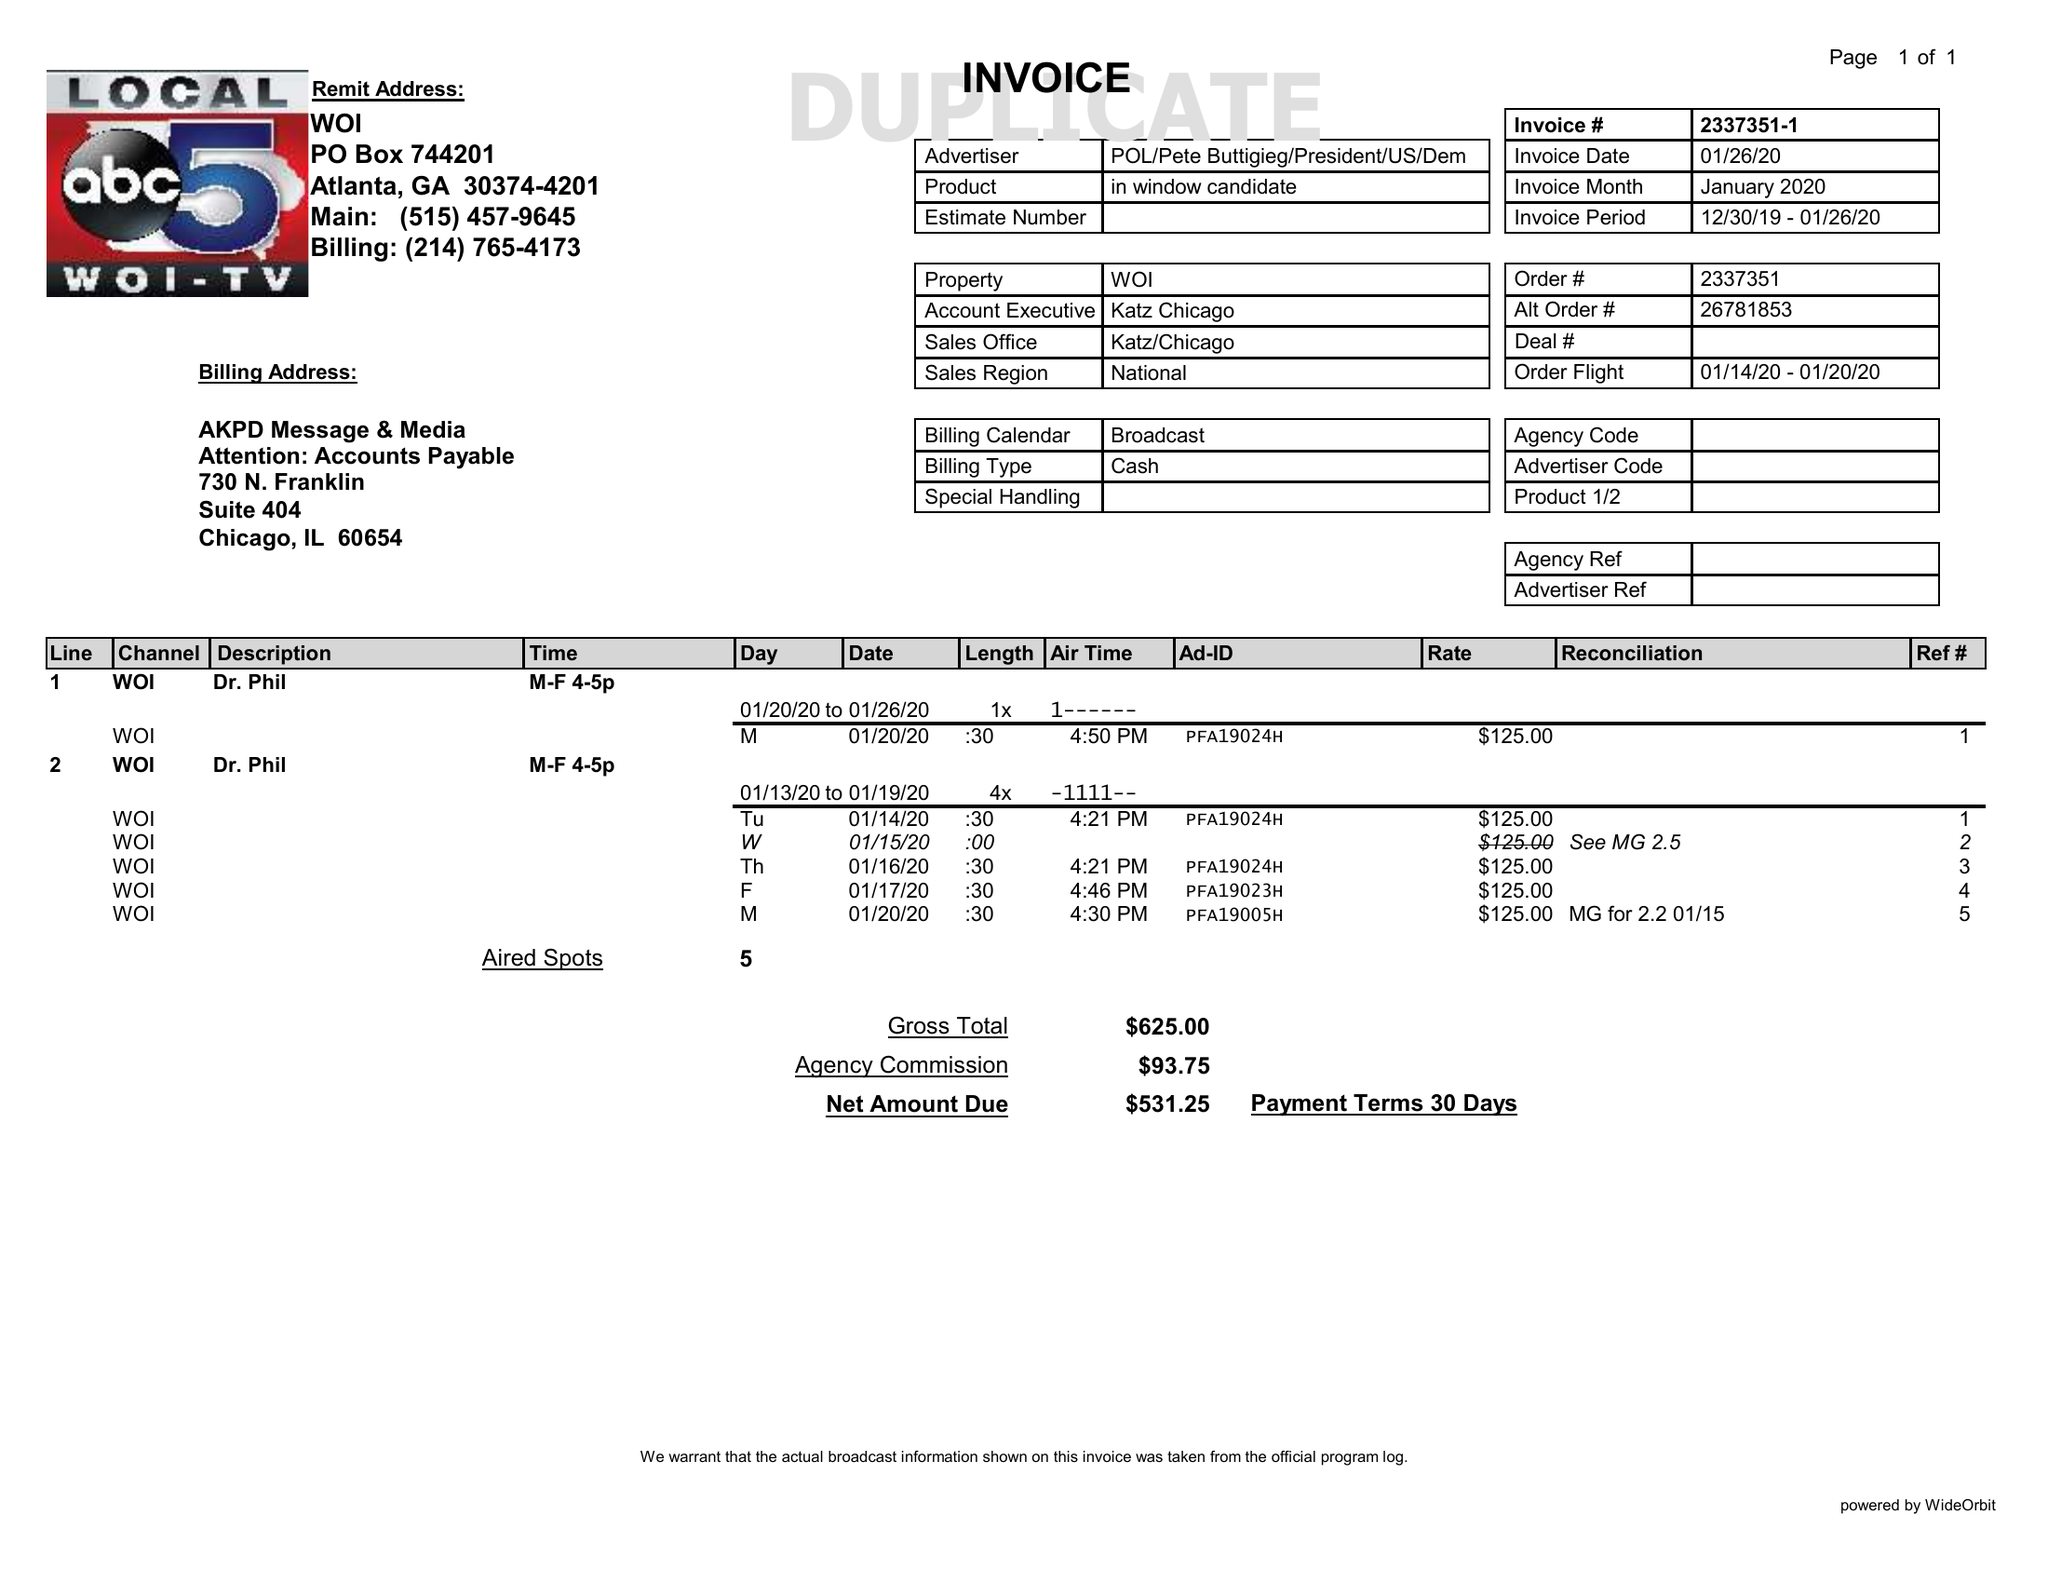What is the value for the gross_amount?
Answer the question using a single word or phrase. 625.00 